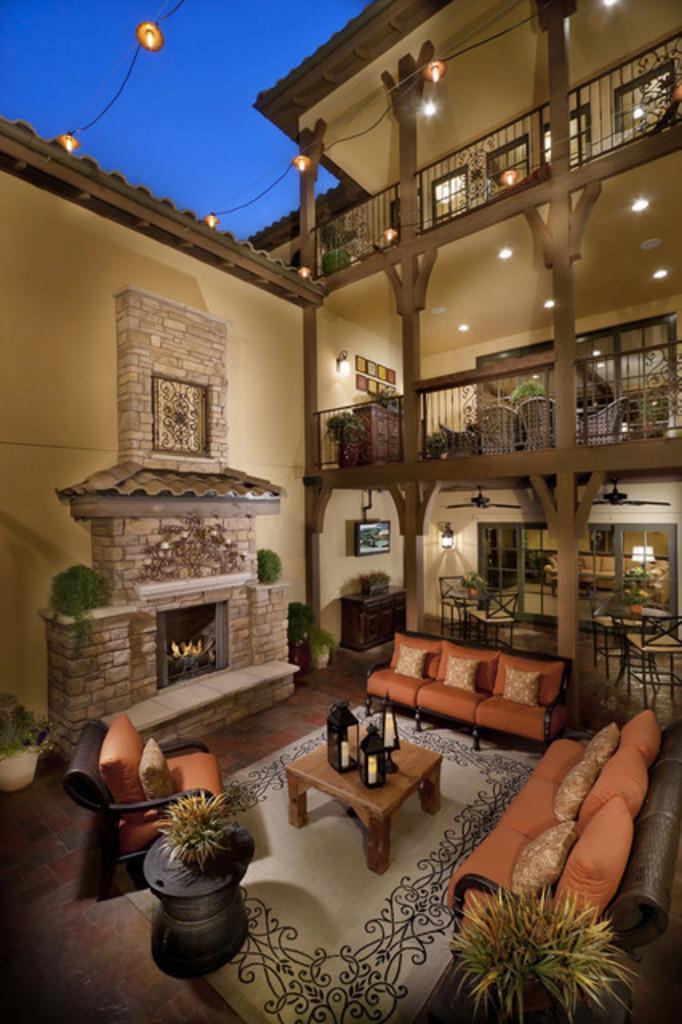Please provide a concise description of this image. Here we can see a house and here there are sofa and couches and chairs and here there is a table placed, at the left side there is a fire stock and there are various lights here and there, here at the right end we can see a plant 